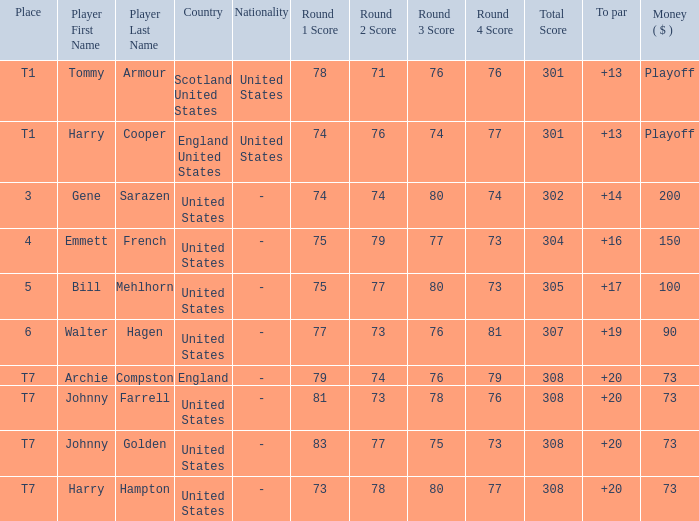What is the rating for the united states when the sum is $200? 3.0. 